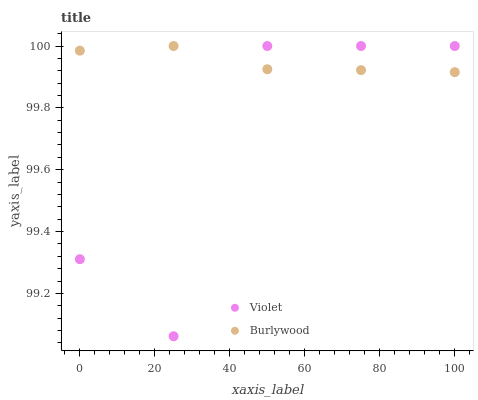Does Violet have the minimum area under the curve?
Answer yes or no. Yes. Does Burlywood have the maximum area under the curve?
Answer yes or no. Yes. Does Violet have the maximum area under the curve?
Answer yes or no. No. Is Burlywood the smoothest?
Answer yes or no. Yes. Is Violet the roughest?
Answer yes or no. Yes. Is Violet the smoothest?
Answer yes or no. No. Does Violet have the lowest value?
Answer yes or no. Yes. Does Violet have the highest value?
Answer yes or no. Yes. Does Violet intersect Burlywood?
Answer yes or no. Yes. Is Violet less than Burlywood?
Answer yes or no. No. Is Violet greater than Burlywood?
Answer yes or no. No. 